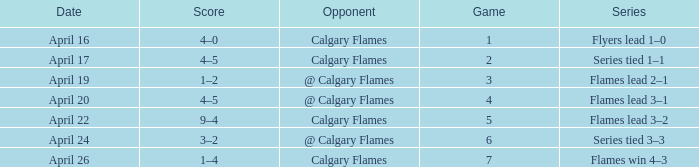Which Date has a Game smaller than 4, and an Opponent of calgary flames, and a Score of 4–5? April 17. 